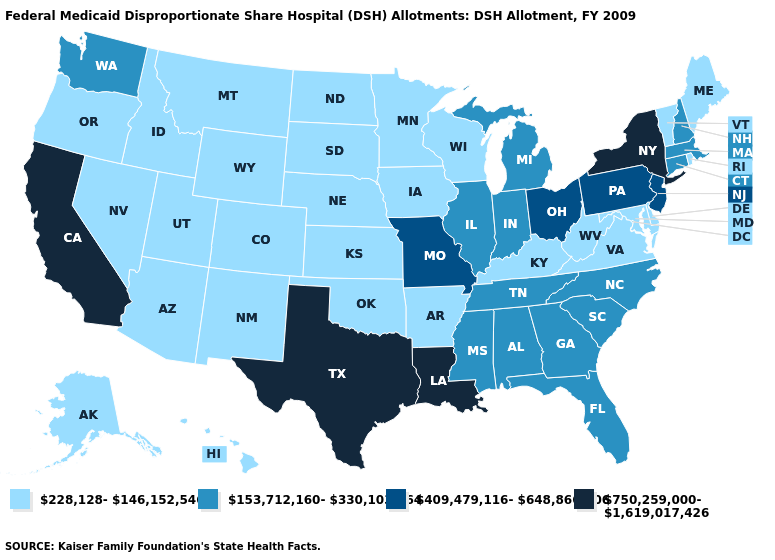Does the first symbol in the legend represent the smallest category?
Answer briefly. Yes. What is the value of Rhode Island?
Answer briefly. 228,128-146,152,546. How many symbols are there in the legend?
Answer briefly. 4. Which states have the lowest value in the West?
Keep it brief. Alaska, Arizona, Colorado, Hawaii, Idaho, Montana, Nevada, New Mexico, Oregon, Utah, Wyoming. What is the lowest value in the USA?
Short answer required. 228,128-146,152,546. Does New Mexico have the highest value in the West?
Short answer required. No. Does Washington have the lowest value in the USA?
Answer briefly. No. Which states have the highest value in the USA?
Quick response, please. California, Louisiana, New York, Texas. What is the lowest value in states that border Montana?
Answer briefly. 228,128-146,152,546. What is the value of New Mexico?
Keep it brief. 228,128-146,152,546. What is the highest value in the USA?
Be succinct. 750,259,000-1,619,017,426. Does Kentucky have a lower value than Wyoming?
Quick response, please. No. Name the states that have a value in the range 750,259,000-1,619,017,426?
Keep it brief. California, Louisiana, New York, Texas. Is the legend a continuous bar?
Quick response, please. No. Among the states that border Wisconsin , which have the lowest value?
Give a very brief answer. Iowa, Minnesota. 